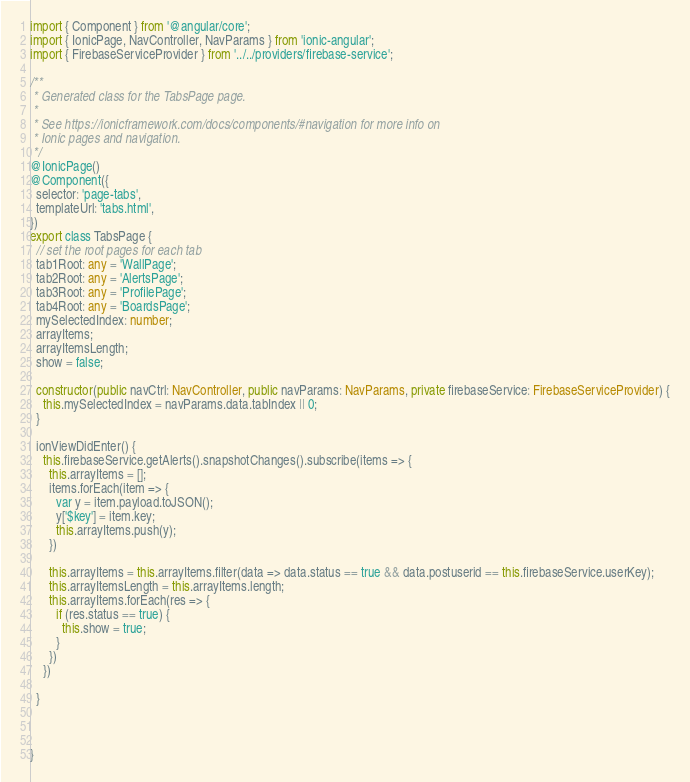Convert code to text. <code><loc_0><loc_0><loc_500><loc_500><_TypeScript_>import { Component } from '@angular/core';
import { IonicPage, NavController, NavParams } from 'ionic-angular';
import { FirebaseServiceProvider } from '../../providers/firebase-service';

/**
 * Generated class for the TabsPage page.
 *
 * See https://ionicframework.com/docs/components/#navigation for more info on
 * Ionic pages and navigation.
 */
@IonicPage()
@Component({
  selector: 'page-tabs',
  templateUrl: 'tabs.html',
})
export class TabsPage {
  // set the root pages for each tab
  tab1Root: any = 'WallPage';
  tab2Root: any = 'AlertsPage';
  tab3Root: any = 'ProfilePage';
  tab4Root: any = 'BoardsPage';
  mySelectedIndex: number;
  arrayItems;
  arrayItemsLength;
  show = false;

  constructor(public navCtrl: NavController, public navParams: NavParams, private firebaseService: FirebaseServiceProvider) {
    this.mySelectedIndex = navParams.data.tabIndex || 0;
  }

  ionViewDidEnter() {
    this.firebaseService.getAlerts().snapshotChanges().subscribe(items => {
      this.arrayItems = [];
      items.forEach(item => {
        var y = item.payload.toJSON();
        y['$key'] = item.key;
        this.arrayItems.push(y);
      })

      this.arrayItems = this.arrayItems.filter(data => data.status == true && data.postuserid == this.firebaseService.userKey);
      this.arrayItemsLength = this.arrayItems.length;
      this.arrayItems.forEach(res => {
        if (res.status == true) {
          this.show = true;
        }
      })
    })

  }
  


}
</code> 